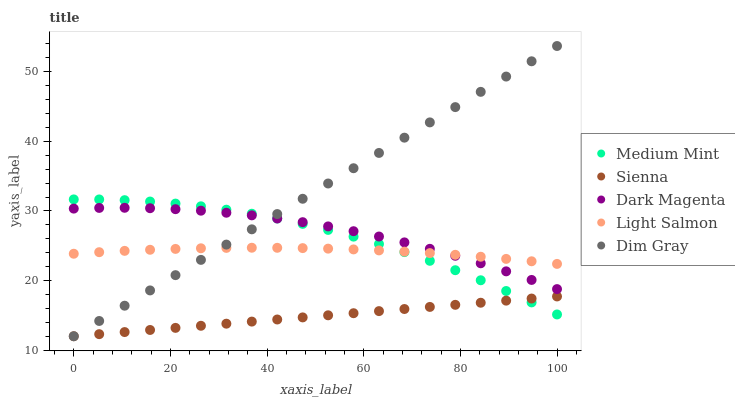Does Sienna have the minimum area under the curve?
Answer yes or no. Yes. Does Dim Gray have the maximum area under the curve?
Answer yes or no. Yes. Does Light Salmon have the minimum area under the curve?
Answer yes or no. No. Does Light Salmon have the maximum area under the curve?
Answer yes or no. No. Is Sienna the smoothest?
Answer yes or no. Yes. Is Medium Mint the roughest?
Answer yes or no. Yes. Is Light Salmon the smoothest?
Answer yes or no. No. Is Light Salmon the roughest?
Answer yes or no. No. Does Sienna have the lowest value?
Answer yes or no. Yes. Does Light Salmon have the lowest value?
Answer yes or no. No. Does Dim Gray have the highest value?
Answer yes or no. Yes. Does Light Salmon have the highest value?
Answer yes or no. No. Is Sienna less than Light Salmon?
Answer yes or no. Yes. Is Light Salmon greater than Sienna?
Answer yes or no. Yes. Does Dim Gray intersect Medium Mint?
Answer yes or no. Yes. Is Dim Gray less than Medium Mint?
Answer yes or no. No. Is Dim Gray greater than Medium Mint?
Answer yes or no. No. Does Sienna intersect Light Salmon?
Answer yes or no. No. 